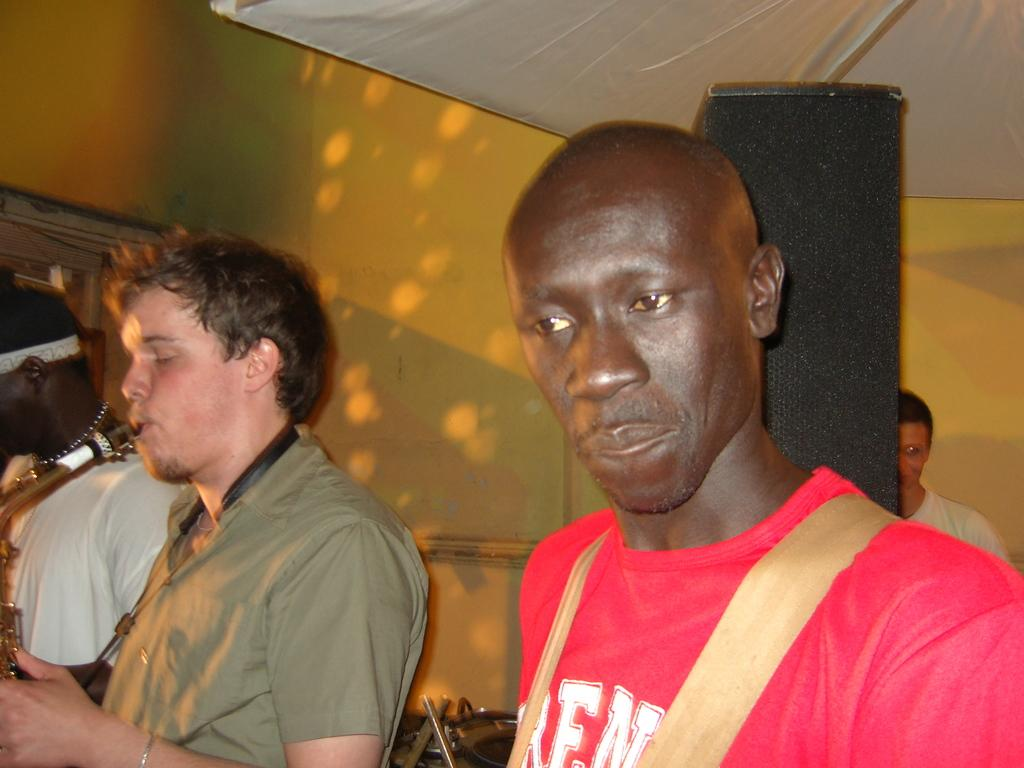Who or what can be seen in the image? There are people in the image. What can be seen in the distance or behind the people? There are objects in the background of the image. What type of structure is visible in the background? There is a wall in the background of the image. Can you see any snakes slithering on the wall in the image? There are no snakes visible in the image. What type of growth or development can be observed in the people in the image? The provided facts do not mention any growth or development in the people, so it cannot be determined from the image. 